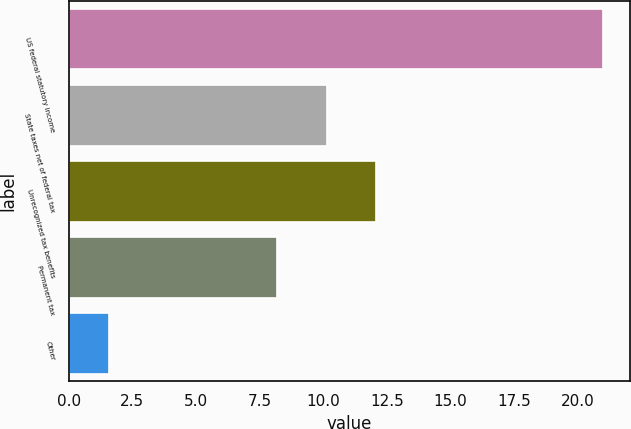Convert chart. <chart><loc_0><loc_0><loc_500><loc_500><bar_chart><fcel>US federal statutory income<fcel>State taxes net of federal tax<fcel>Unrecognized tax benefits<fcel>Permanent tax<fcel>Other<nl><fcel>21<fcel>10.14<fcel>12.08<fcel>8.2<fcel>1.6<nl></chart> 